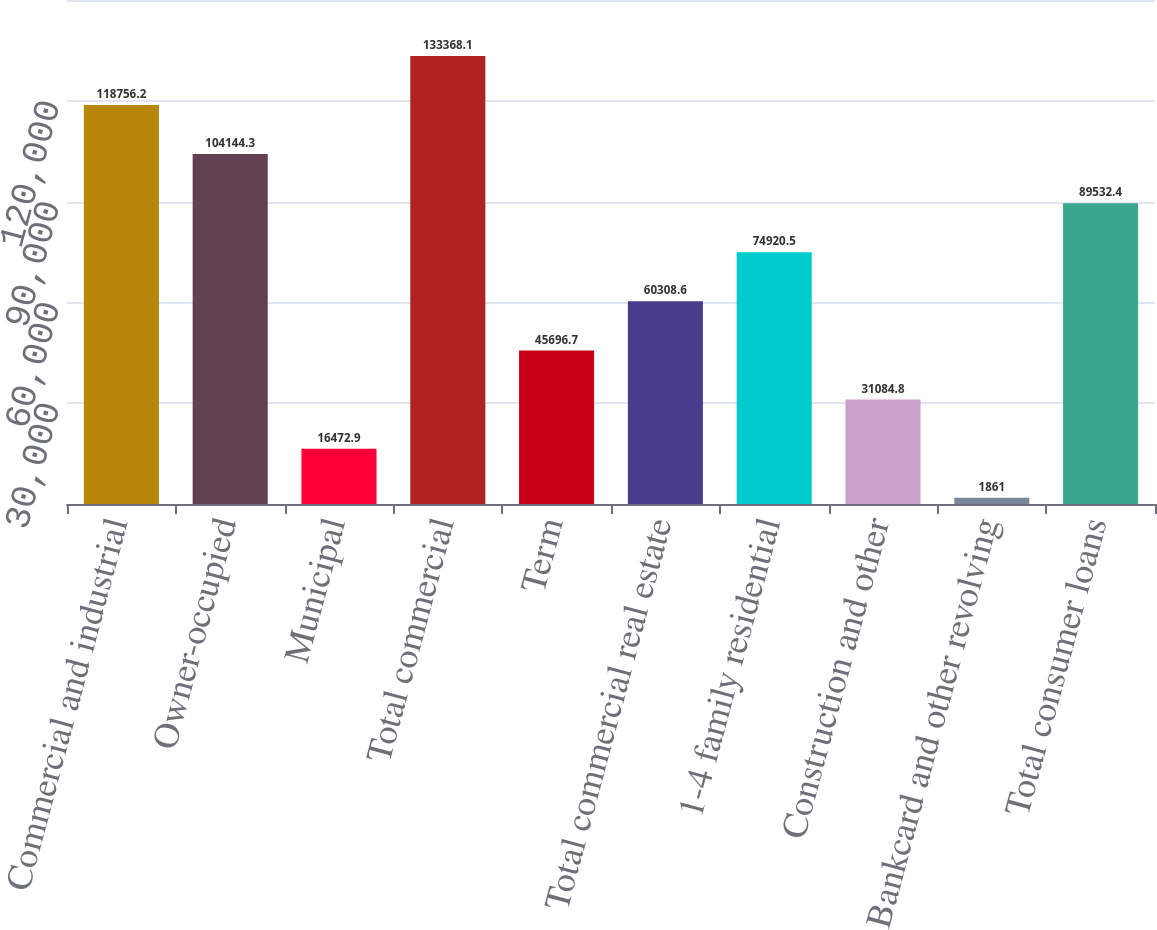<chart> <loc_0><loc_0><loc_500><loc_500><bar_chart><fcel>Commercial and industrial<fcel>Owner-occupied<fcel>Municipal<fcel>Total commercial<fcel>Term<fcel>Total commercial real estate<fcel>1-4 family residential<fcel>Construction and other<fcel>Bankcard and other revolving<fcel>Total consumer loans<nl><fcel>118756<fcel>104144<fcel>16472.9<fcel>133368<fcel>45696.7<fcel>60308.6<fcel>74920.5<fcel>31084.8<fcel>1861<fcel>89532.4<nl></chart> 